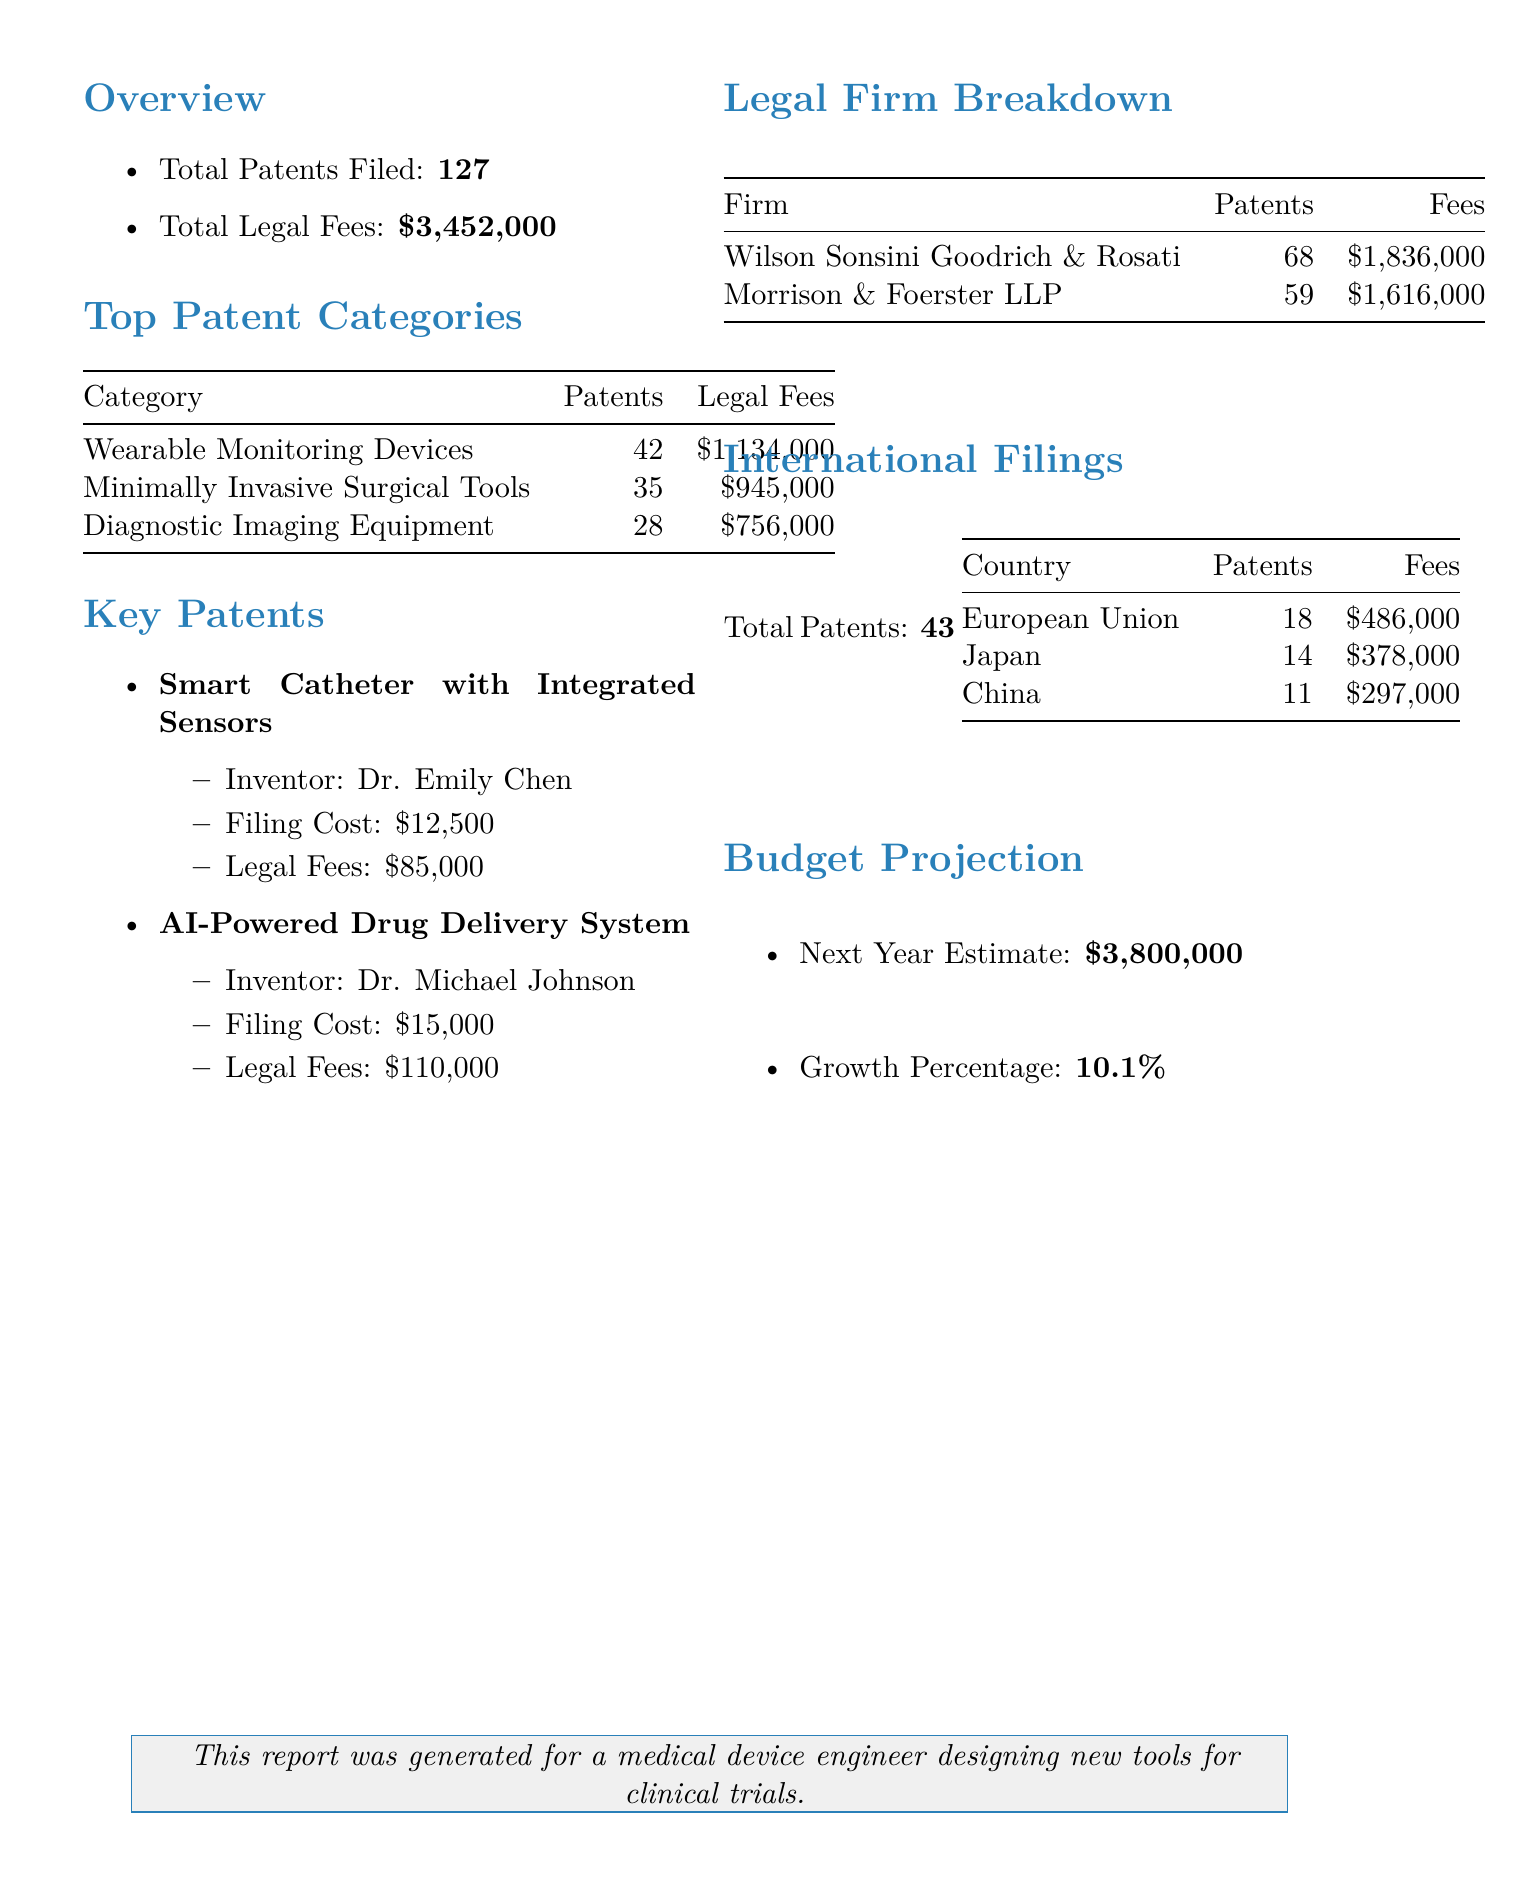What is the total number of patents filed? The total number of patents filed in the document is explicitly stated in the overview section.
Answer: 127 What are the legal fees associated with wearable monitoring devices? The document provides a breakdown of legal fees for each patent category, including wearable monitoring devices.
Answer: $1,134,000 Who invented the smart catheter with integrated sensors? The key patents section lists the inventors of the highlighted patents.
Answer: Dr. Emily Chen How many countries were involved in international filings? The document lists the countries associated with international filings under a specific section.
Answer: 3 What is the legal fee paid to Wilson Sonsini Goodrich & Rosati? The legal firm breakdown shows the total fees associated with Wilson Sonsini Goodrich & Rosati.
Answer: $1,836,000 What is the estimated budget for next year? The budget projection section provides the estimate for the next year's budget.
Answer: $3,800,000 Which category has the highest number of patents filed? The top patent categories section lists the categories with their corresponding patent counts, revealing the one with the highest count.
Answer: Wearable Monitoring Devices What was the filing cost for the AI-powered drug delivery system? The key patents section mentions the filing cost for the AI-powered drug delivery system.
Answer: $15,000 What is the growth percentage for next year's budget projection? The budget projection section explicitly states the anticipated growth percentage for the next year's budget.
Answer: 10.1% 